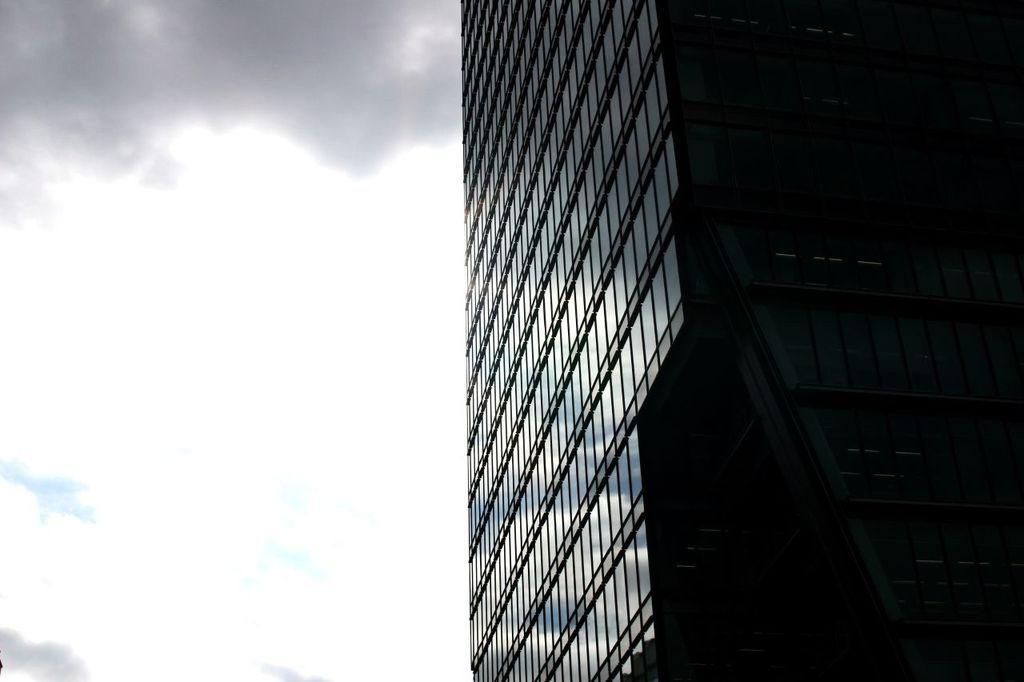Could you give a brief overview of what you see in this image? On the left side of the image I can see a cloudy sky. On the right side of the image there is a building. 